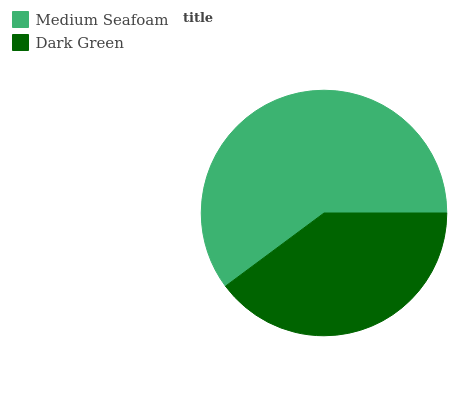Is Dark Green the minimum?
Answer yes or no. Yes. Is Medium Seafoam the maximum?
Answer yes or no. Yes. Is Dark Green the maximum?
Answer yes or no. No. Is Medium Seafoam greater than Dark Green?
Answer yes or no. Yes. Is Dark Green less than Medium Seafoam?
Answer yes or no. Yes. Is Dark Green greater than Medium Seafoam?
Answer yes or no. No. Is Medium Seafoam less than Dark Green?
Answer yes or no. No. Is Medium Seafoam the high median?
Answer yes or no. Yes. Is Dark Green the low median?
Answer yes or no. Yes. Is Dark Green the high median?
Answer yes or no. No. Is Medium Seafoam the low median?
Answer yes or no. No. 